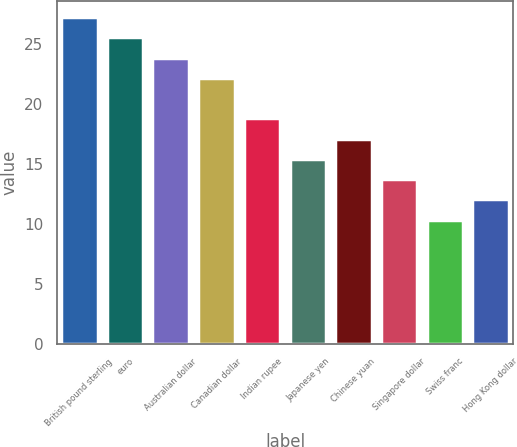Convert chart to OTSL. <chart><loc_0><loc_0><loc_500><loc_500><bar_chart><fcel>British pound sterling<fcel>euro<fcel>Australian dollar<fcel>Canadian dollar<fcel>Indian rupee<fcel>Japanese yen<fcel>Chinese yuan<fcel>Singapore dollar<fcel>Swiss franc<fcel>Hong Kong dollar<nl><fcel>27.24<fcel>25.55<fcel>23.86<fcel>22.17<fcel>18.79<fcel>15.41<fcel>17.1<fcel>13.72<fcel>10.34<fcel>12.03<nl></chart> 